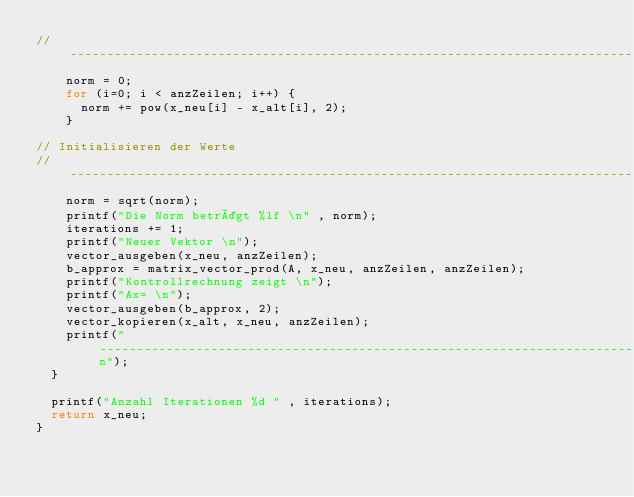Convert code to text. <code><loc_0><loc_0><loc_500><loc_500><_C_>//---------------------------------------------------------------------------------------------------------------------
    norm = 0;
    for (i=0; i < anzZeilen; i++) {
      norm += pow(x_neu[i] - x_alt[i], 2);
    }

// Initialisieren der Werte
//---------------------------------------------------------------------------------------------------------------------
    norm = sqrt(norm);
    printf("Die Norm beträgt %lf \n" , norm);
    iterations += 1;
    printf("Neuer Vektor \n");
    vector_ausgeben(x_neu, anzZeilen);
    b_approx = matrix_vector_prod(A, x_neu, anzZeilen, anzZeilen);
    printf("Kontrollrechnung zeigt \n");
    printf("Ax= \n");
    vector_ausgeben(b_approx, 2);
    vector_kopieren(x_alt, x_neu, anzZeilen);
    printf("-----------------------------------------------------------------------------------------------------------\n");
  }

  printf("Anzahl Iterationen %d " , iterations);
  return x_neu;
}
</code> 